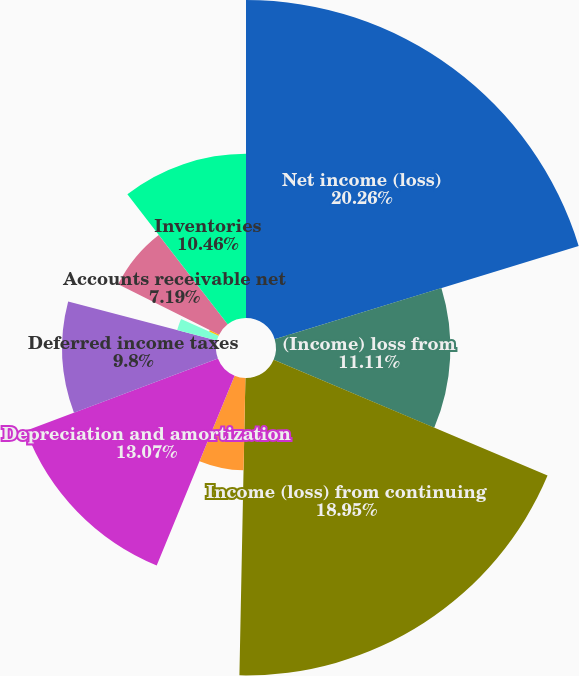Convert chart to OTSL. <chart><loc_0><loc_0><loc_500><loc_500><pie_chart><fcel>Net income (loss)<fcel>(Income) loss from<fcel>Income (loss) from continuing<fcel>Non-cash restructuring and<fcel>Depreciation and amortization<fcel>Deferred income taxes<fcel>Provision for losses on<fcel>Other<fcel>Accounts receivable net<fcel>Inventories<nl><fcel>20.26%<fcel>11.11%<fcel>18.95%<fcel>5.88%<fcel>13.07%<fcel>9.8%<fcel>2.62%<fcel>0.66%<fcel>7.19%<fcel>10.46%<nl></chart> 